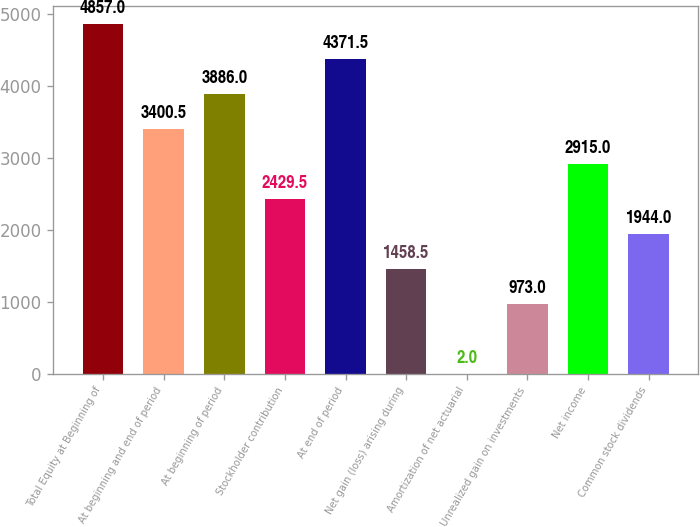Convert chart to OTSL. <chart><loc_0><loc_0><loc_500><loc_500><bar_chart><fcel>Total Equity at Beginning of<fcel>At beginning and end of period<fcel>At beginning of period<fcel>Stockholder contribution<fcel>At end of period<fcel>Net gain (loss) arising during<fcel>Amortization of net actuarial<fcel>Unrealized gain on investments<fcel>Net income<fcel>Common stock dividends<nl><fcel>4857<fcel>3400.5<fcel>3886<fcel>2429.5<fcel>4371.5<fcel>1458.5<fcel>2<fcel>973<fcel>2915<fcel>1944<nl></chart> 